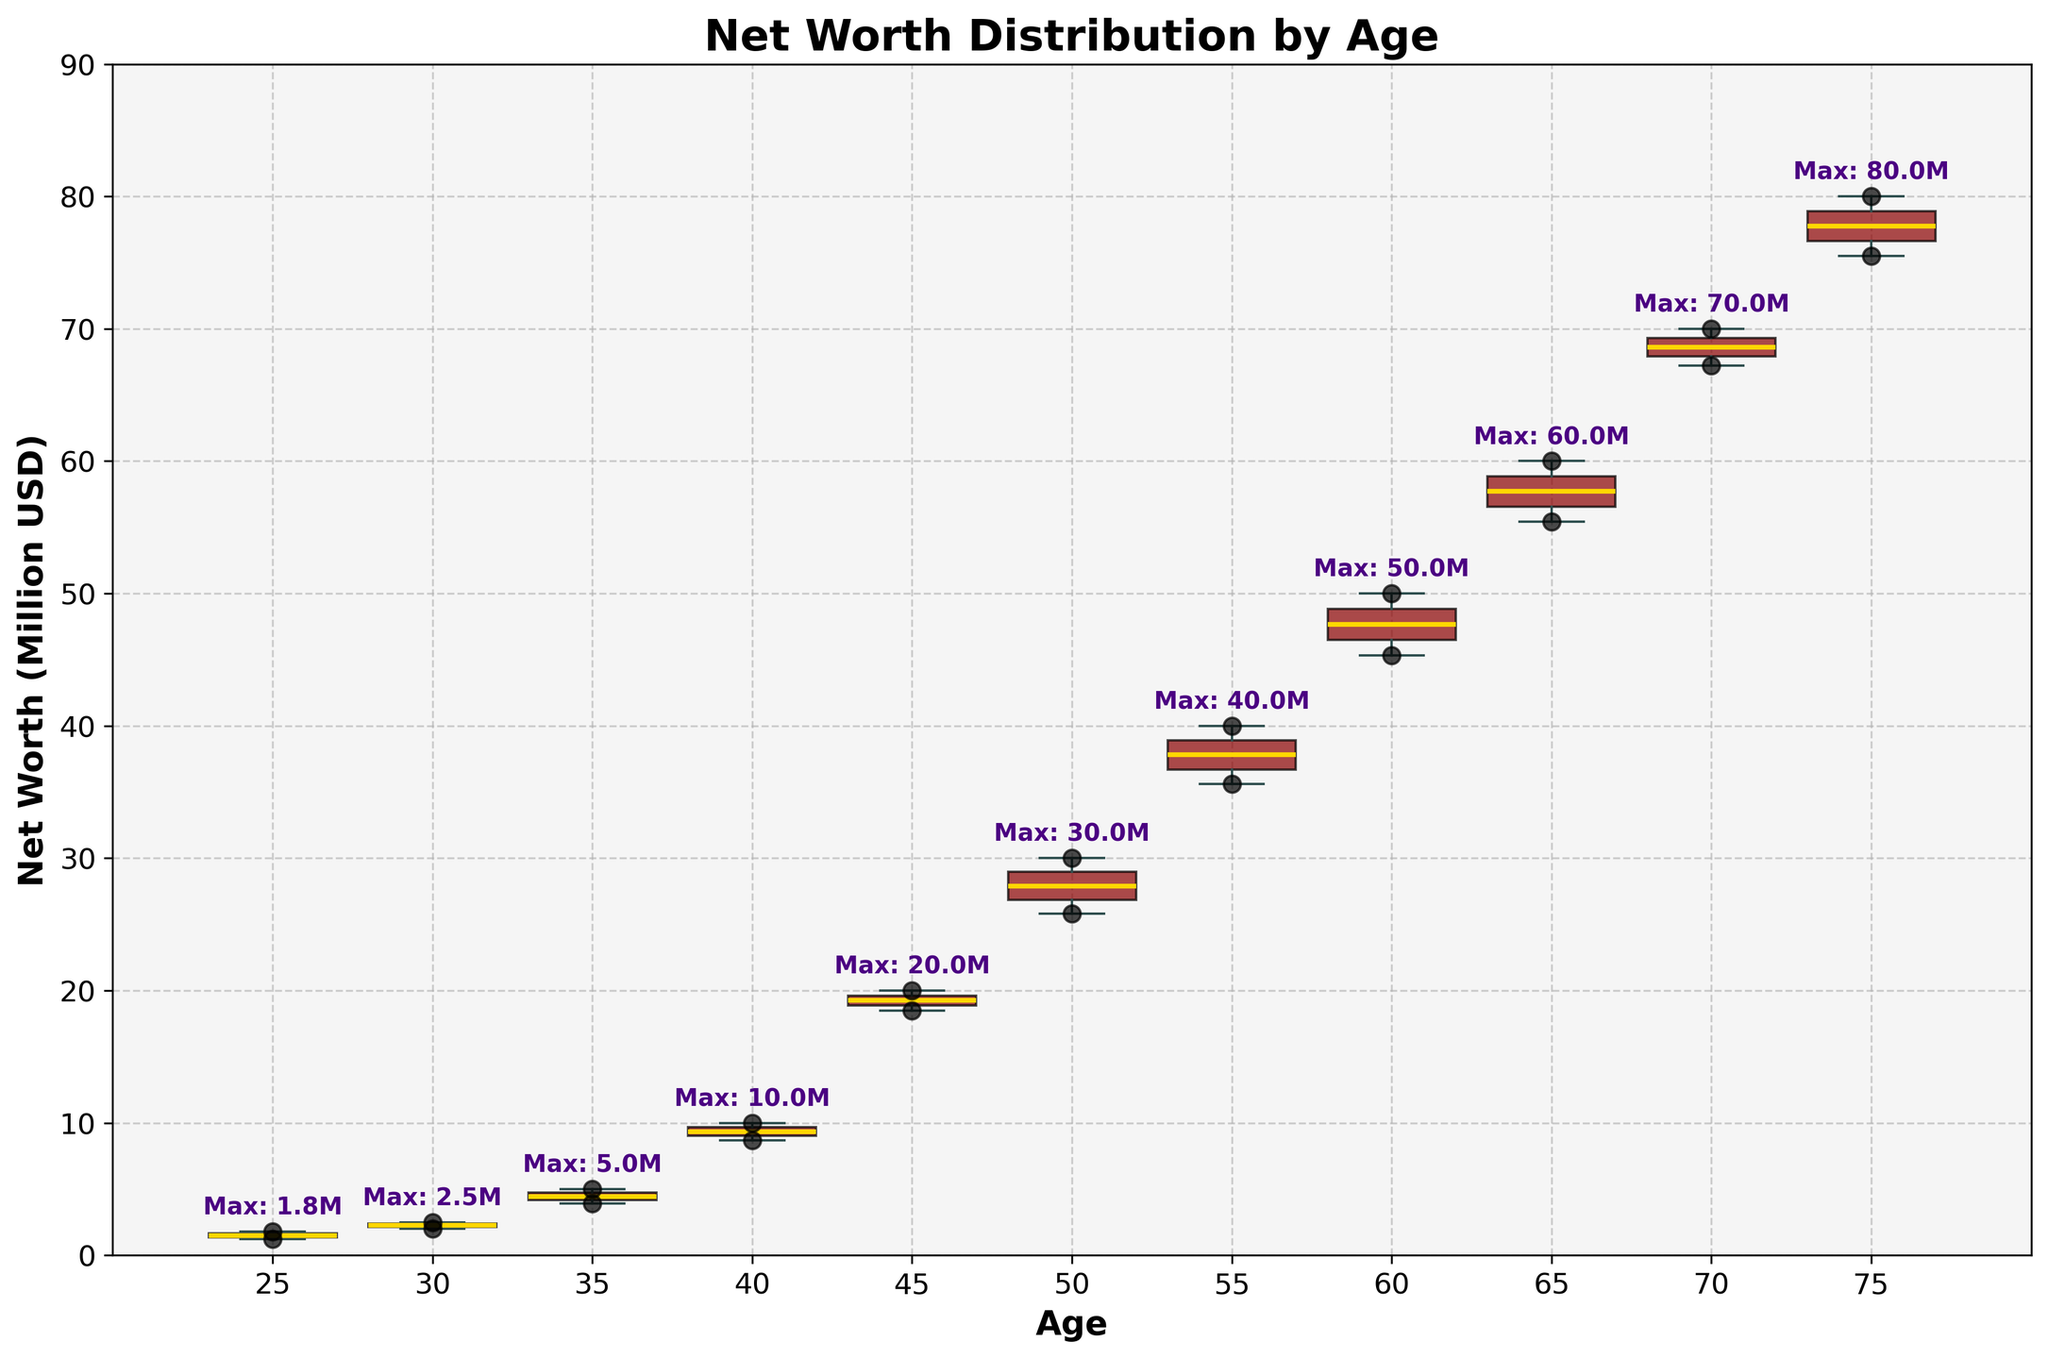How is the net worth distributed across different age groups? To determine the distribution of net worth across different age groups, observe the box plots. Each box represents the interquartile range (IQR) of net worth within the age group, the median line within the box, and the whiskers extending to the minimum and maximum values excluding outliers. The scatter points visualize individual data points.
Answer: The net worth varies significantly across ages, with higher variances and values observed in older age groups What is the median net worth for individuals aged 55? Look at the line inside the box plot for the age 55 group. This line represents the median net worth for that age group.
Answer: 37.8 million USD Which age group has the highest maximum net worth? Check the annotations for maximum values above each box plot. The age group with the highest annotated value will have the highest maximum net worth.
Answer: 75 (80 million USD) Are there any age groups without outliers in net worth? Identify if any age groups do not have scatter points outside the whiskers of their box plots, which would indicate the absence of outliers.
Answer: Yes, ages 25, 35, 45, and 60 How does the interquartile range (IQR) of net worth change with age? To understand the change, visually compare the height of the boxes from different age groups, as the height of each box represents the IQR.
Answer: The IQR generally increases with age What is the difference in the maximum net worth between the age groups 40 and 50? Look at the annotated maximum net worth values for the age groups 40 and 50. Calculate the difference between these values.
Answer: 20 million USD Which age group shows the least variation in net worth? Assess the dispersion of the data points and the size of the IQR. The group with the smallest IQR and less spread of scatter points has the least variation.
Answer: 25 What is the spread of net worth for the age group 30? Observe the position of the whiskers and dots around the age 30 box plot and find the minimum and maximum values of the scatter points.
Answer: 2.0 to 2.5 million USD Is there a noticeable trend in net worth as age increases? Examine the box plots and scatter points across different ages. Look for patterns such as increasing median lines and expanding IQRs.
Answer: Yes, net worth tends to increase with age What is the median net worth for the youngest age group compared to the oldest? Check the median line in the box plots for ages 25 and 75. Compare the values indicated by these lines.
Answer: Youngest: 1.5 million USD, Oldest: 77.75 million USD 